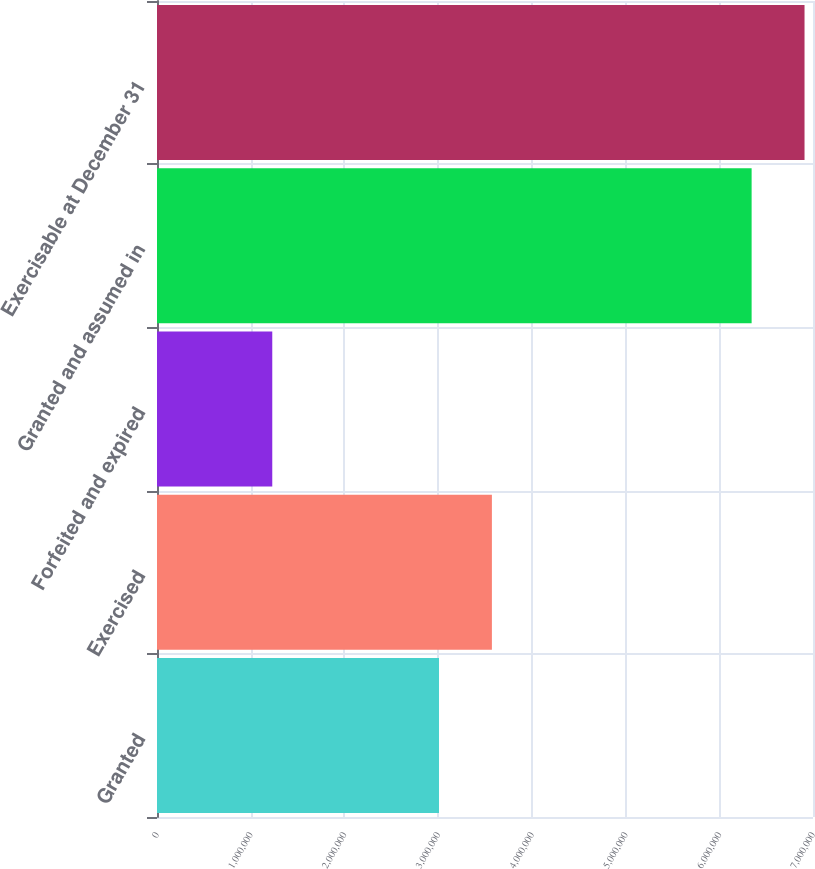Convert chart to OTSL. <chart><loc_0><loc_0><loc_500><loc_500><bar_chart><fcel>Granted<fcel>Exercised<fcel>Forfeited and expired<fcel>Granted and assumed in<fcel>Exercisable at December 31<nl><fcel>3.009e+06<fcel>3.5736e+06<fcel>1.23e+06<fcel>6.345e+06<fcel>6.9096e+06<nl></chart> 